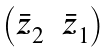<formula> <loc_0><loc_0><loc_500><loc_500>\begin{pmatrix} \bar { z } _ { 2 } & \bar { z } _ { 1 } \end{pmatrix}</formula> 